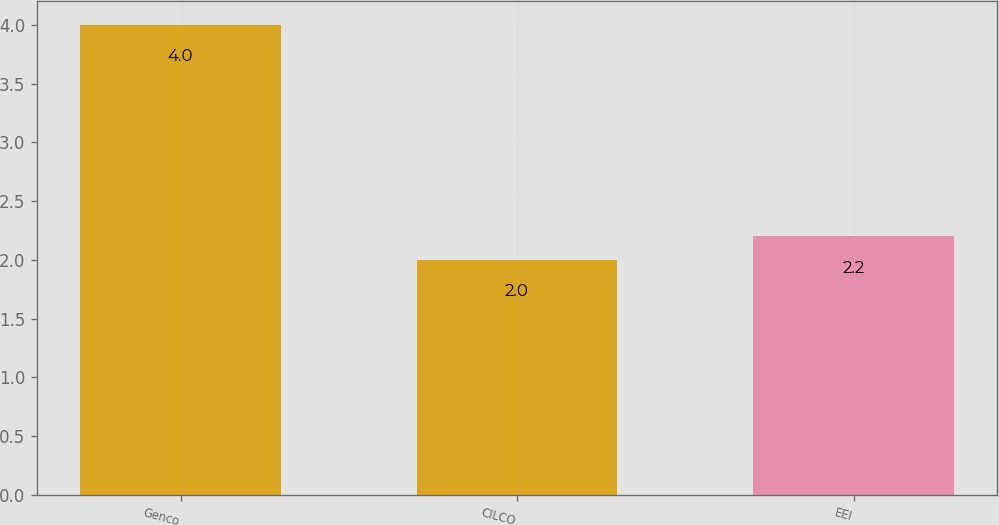Convert chart. <chart><loc_0><loc_0><loc_500><loc_500><bar_chart><fcel>Genco<fcel>CILCO<fcel>EEI<nl><fcel>4<fcel>2<fcel>2.2<nl></chart> 